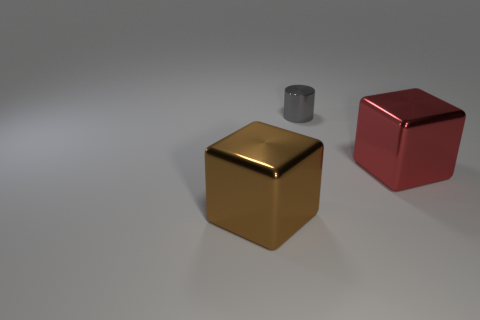Is there any other thing that is the same size as the gray cylinder?
Make the answer very short. No. Is there anything else that has the same shape as the small thing?
Keep it short and to the point. No. Are there fewer gray things that are to the right of the cylinder than large brown blocks that are right of the brown block?
Your response must be concise. No. Do the big red thing and the small thing have the same material?
Your answer should be compact. Yes. What size is the object that is both on the left side of the red metallic cube and in front of the small cylinder?
Your answer should be very brief. Large. There is a large object that is to the right of the cube to the left of the shiny cube right of the small gray shiny object; what is it made of?
Your answer should be compact. Metal. There is a shiny object that is to the right of the metal cylinder; is it the same shape as the big object to the left of the large red cube?
Keep it short and to the point. Yes. How many other objects are there of the same material as the small gray cylinder?
Give a very brief answer. 2. Is the big cube that is to the right of the cylinder made of the same material as the big block that is on the left side of the tiny gray shiny thing?
Make the answer very short. Yes. There is a gray object that is made of the same material as the big red object; what is its shape?
Your answer should be very brief. Cylinder. 